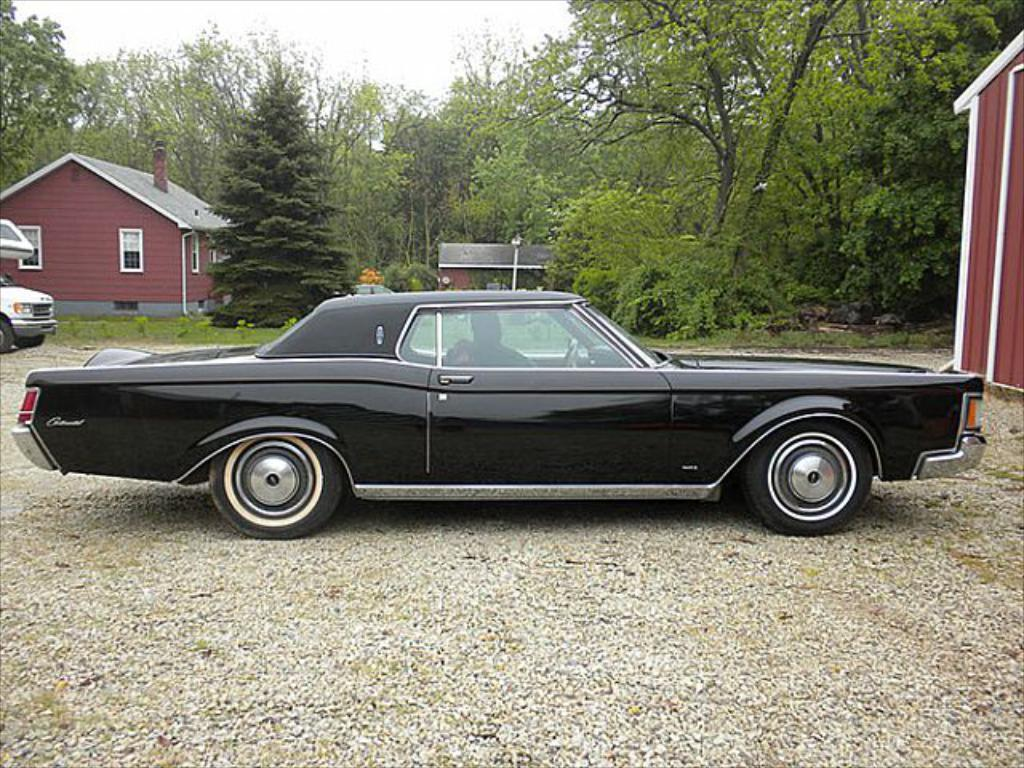What types of objects can be seen in the image? There are vehicles, shelters, trees, and a pole in the image. What is the ground surface like in the image? There is grass in the image. What can be seen in the sky in the image? The sky is visible in the image. Can you describe the person in the image? There is a person inside a car in the image. What type of screw can be seen holding the tree to the ground in the image? There are no screws visible in the image; the tree is not attached to the ground. What color is the copper wire used to stitch the person's clothes in the image? There is no copper wire or stitching visible in the image; the person is inside a car. 